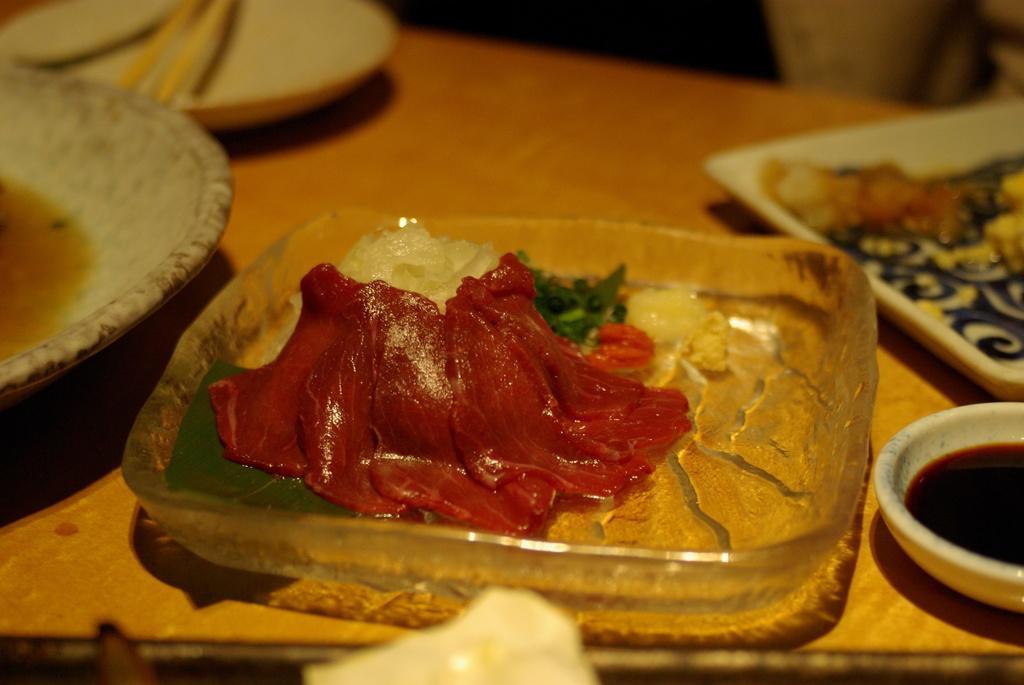How would you summarize this image in a sentence or two? In this picture I can see food in the bowls and a tray and I can see sauce in the bowl and couple of chopsticks in the plate on the table. 